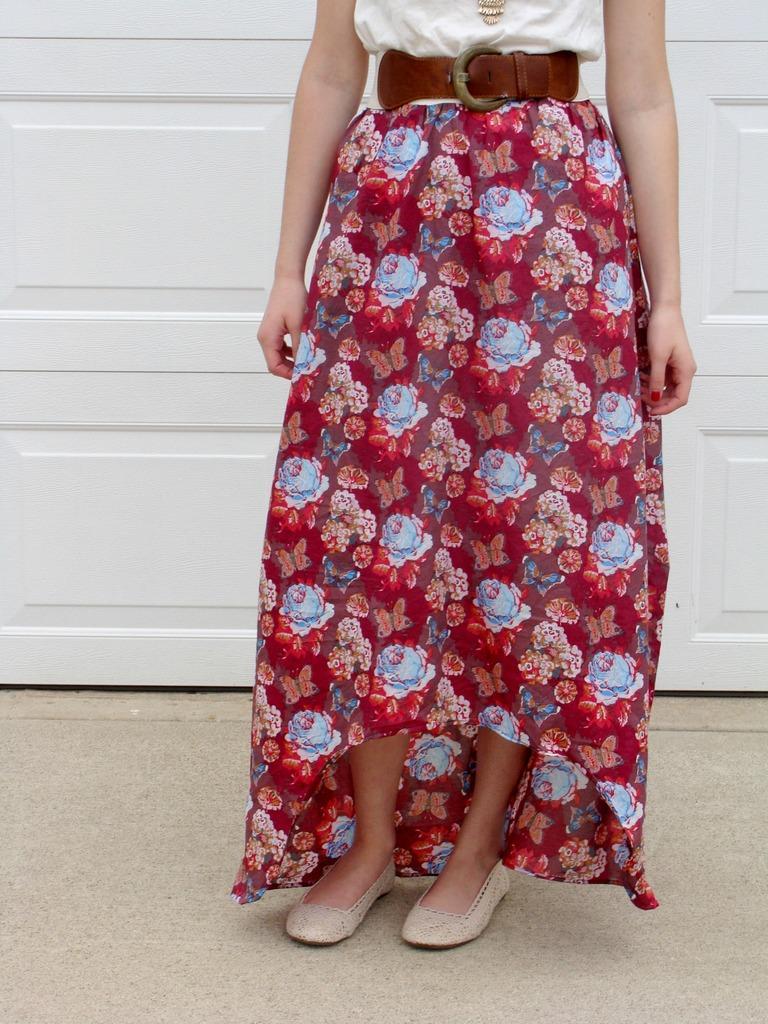In one or two sentences, can you explain what this image depicts? In this picture we observe a woman's skirt and she is also wearing a brown belt. 